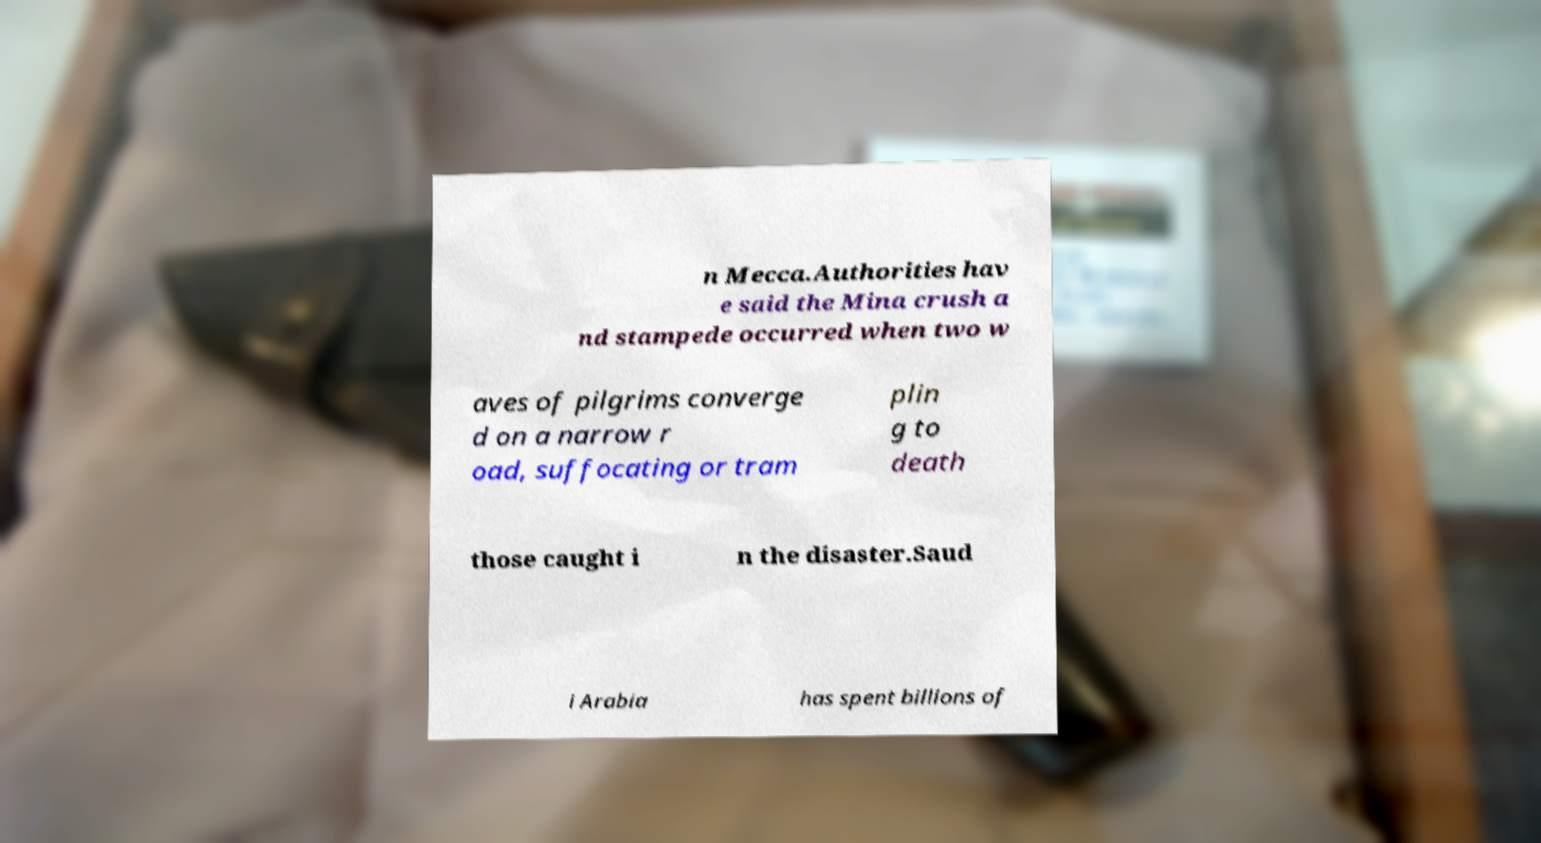What messages or text are displayed in this image? I need them in a readable, typed format. n Mecca.Authorities hav e said the Mina crush a nd stampede occurred when two w aves of pilgrims converge d on a narrow r oad, suffocating or tram plin g to death those caught i n the disaster.Saud i Arabia has spent billions of 